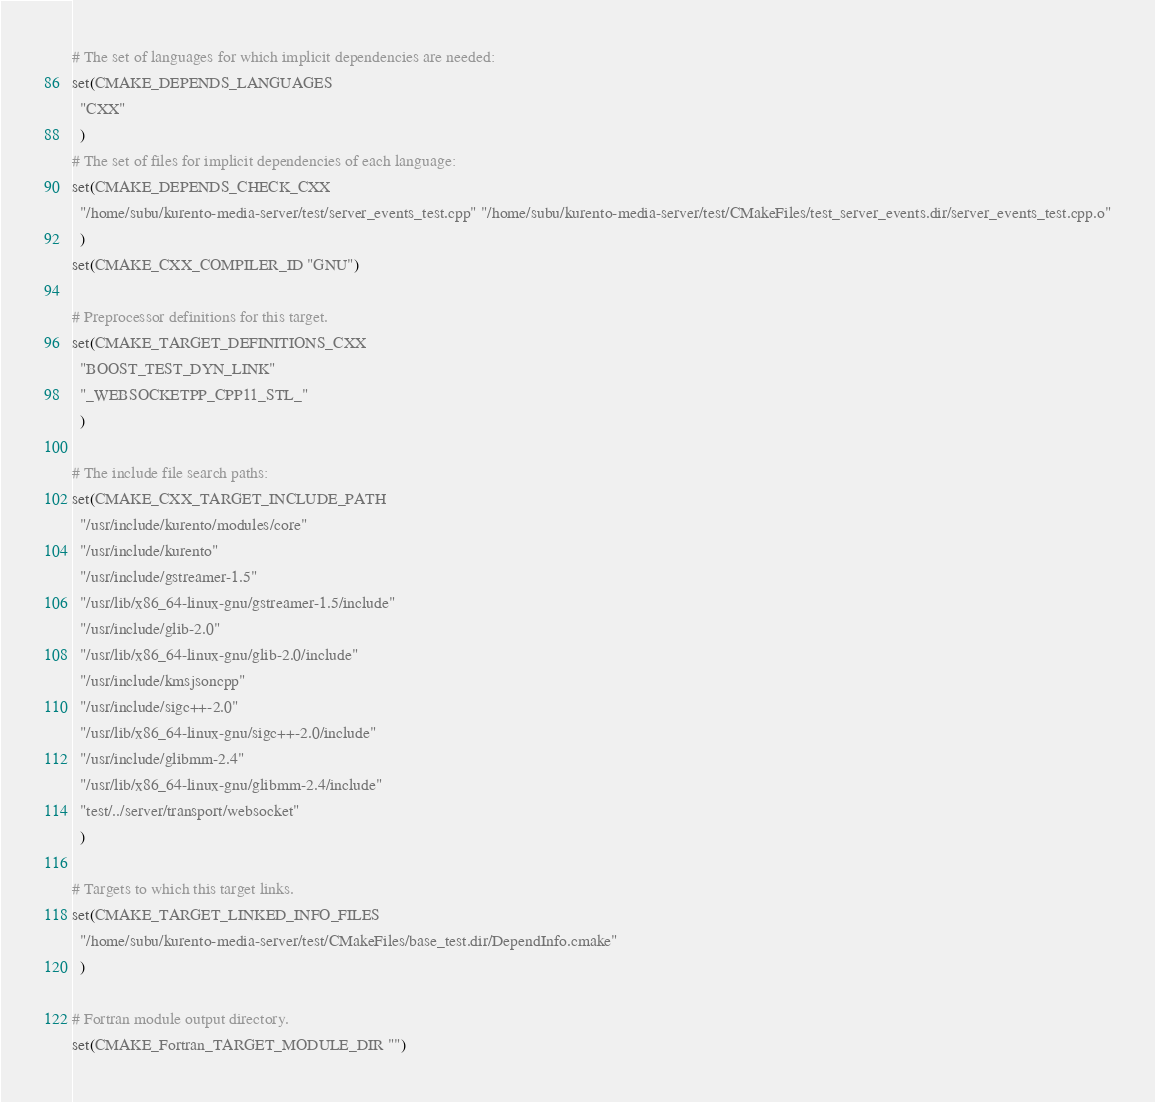Convert code to text. <code><loc_0><loc_0><loc_500><loc_500><_CMake_># The set of languages for which implicit dependencies are needed:
set(CMAKE_DEPENDS_LANGUAGES
  "CXX"
  )
# The set of files for implicit dependencies of each language:
set(CMAKE_DEPENDS_CHECK_CXX
  "/home/subu/kurento-media-server/test/server_events_test.cpp" "/home/subu/kurento-media-server/test/CMakeFiles/test_server_events.dir/server_events_test.cpp.o"
  )
set(CMAKE_CXX_COMPILER_ID "GNU")

# Preprocessor definitions for this target.
set(CMAKE_TARGET_DEFINITIONS_CXX
  "BOOST_TEST_DYN_LINK"
  "_WEBSOCKETPP_CPP11_STL_"
  )

# The include file search paths:
set(CMAKE_CXX_TARGET_INCLUDE_PATH
  "/usr/include/kurento/modules/core"
  "/usr/include/kurento"
  "/usr/include/gstreamer-1.5"
  "/usr/lib/x86_64-linux-gnu/gstreamer-1.5/include"
  "/usr/include/glib-2.0"
  "/usr/lib/x86_64-linux-gnu/glib-2.0/include"
  "/usr/include/kmsjsoncpp"
  "/usr/include/sigc++-2.0"
  "/usr/lib/x86_64-linux-gnu/sigc++-2.0/include"
  "/usr/include/glibmm-2.4"
  "/usr/lib/x86_64-linux-gnu/glibmm-2.4/include"
  "test/../server/transport/websocket"
  )

# Targets to which this target links.
set(CMAKE_TARGET_LINKED_INFO_FILES
  "/home/subu/kurento-media-server/test/CMakeFiles/base_test.dir/DependInfo.cmake"
  )

# Fortran module output directory.
set(CMAKE_Fortran_TARGET_MODULE_DIR "")
</code> 